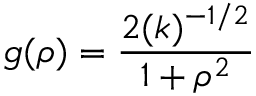Convert formula to latex. <formula><loc_0><loc_0><loc_500><loc_500>g ( \rho ) = \frac { 2 ( k ) ^ { - 1 / 2 } } { 1 + { \rho } ^ { 2 } }</formula> 